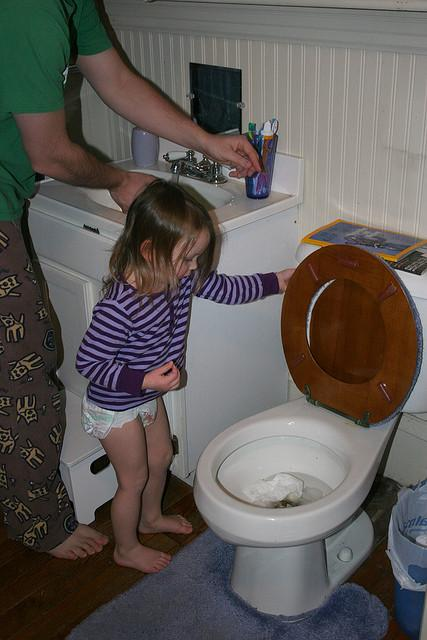What is the toddler about to do? Please explain your reasoning. flush toilet. They are going to flush the toilet after going to the bathroom. 